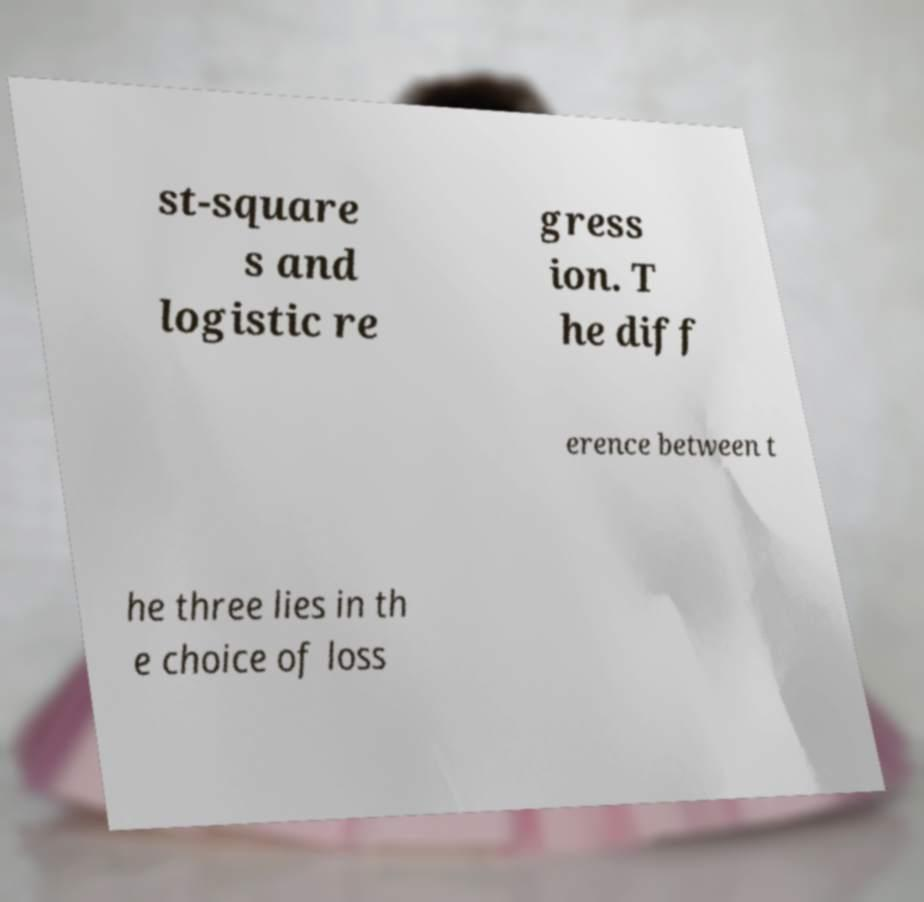Please identify and transcribe the text found in this image. st-square s and logistic re gress ion. T he diff erence between t he three lies in th e choice of loss 